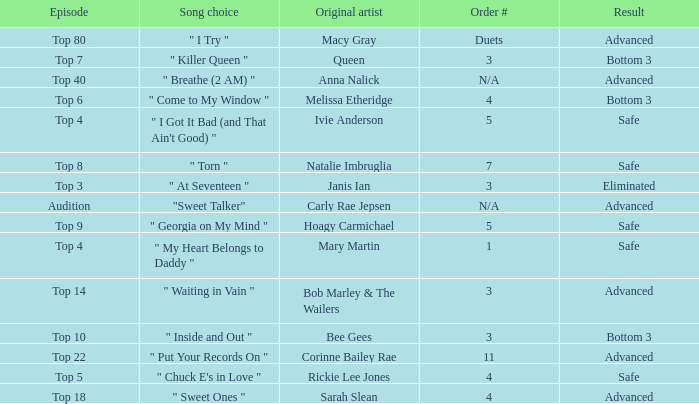What's the original artist of the song performed in the top 3 episode? Janis Ian. 